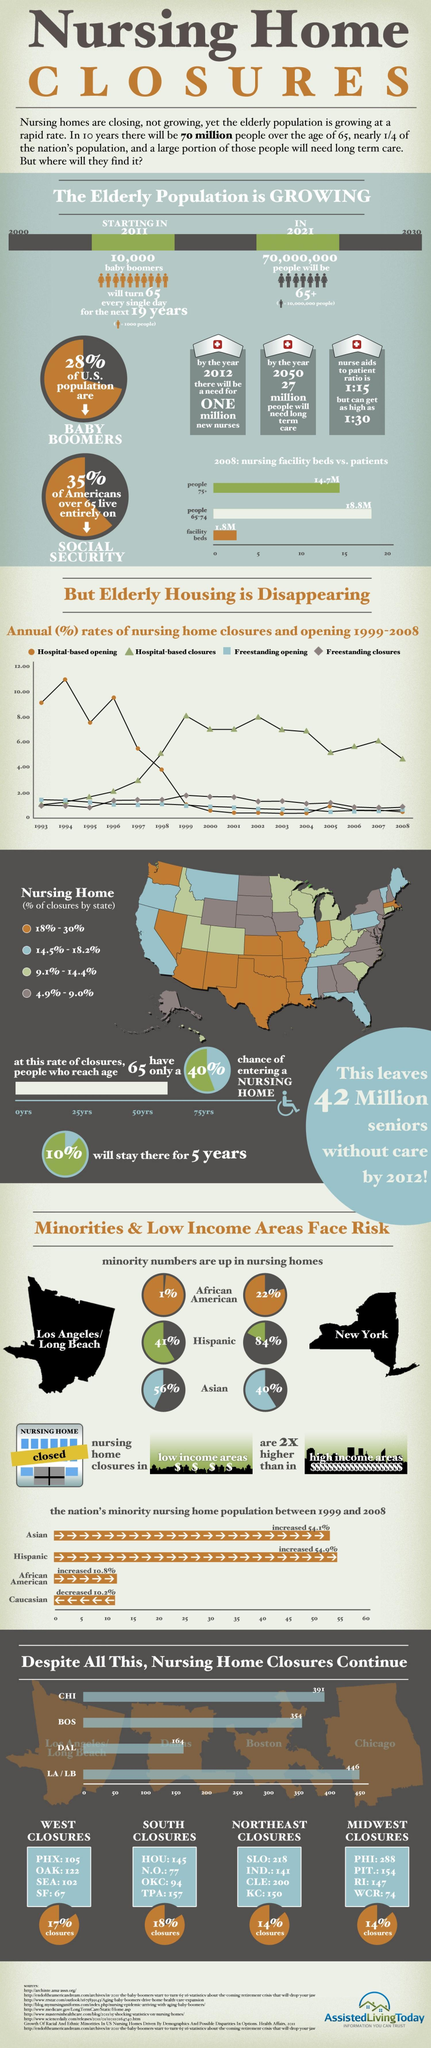What is the percentage of Hispanics in Los Angeles and New York are up in nursing homes, taken together?
Answer the question with a short phrase. 125% What is the percentage of African American in Los Angeles and New York are up in nursing homes, taken together? 23% What percentage of Americans over 65 not live entirely on social security? 65% What percentage of the U.S population are not baby boomers? 72% 